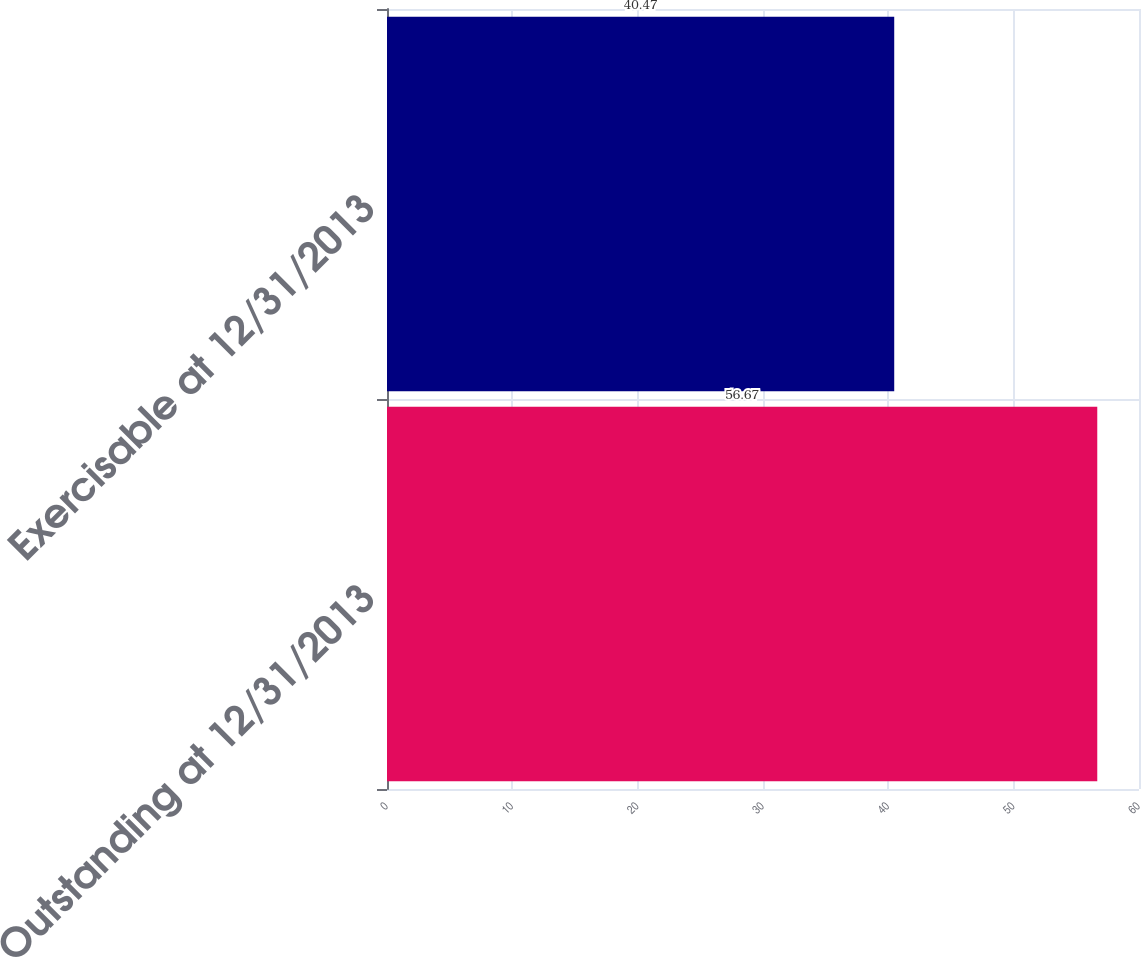Convert chart to OTSL. <chart><loc_0><loc_0><loc_500><loc_500><bar_chart><fcel>Outstanding at 12/31/2013<fcel>Exercisable at 12/31/2013<nl><fcel>56.67<fcel>40.47<nl></chart> 